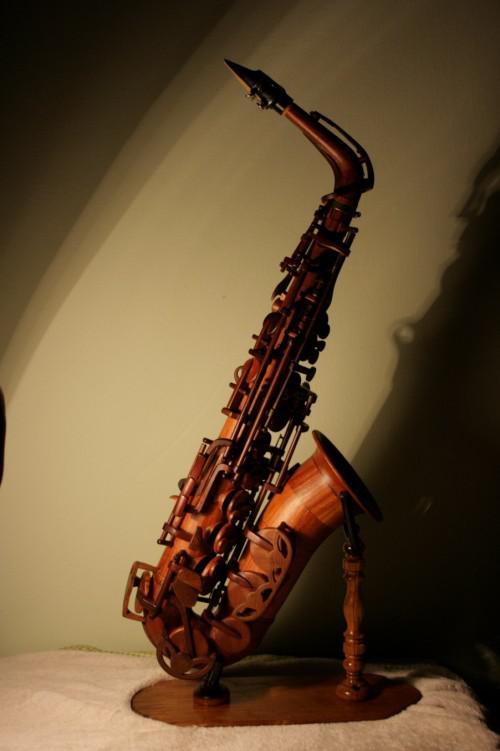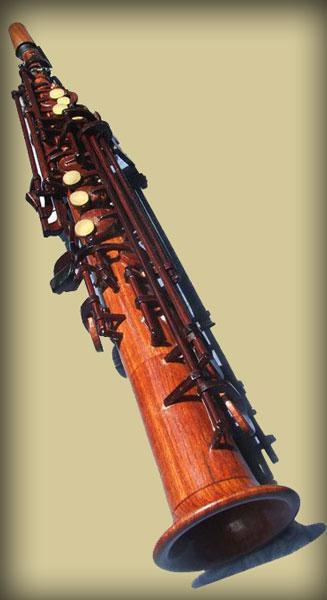The first image is the image on the left, the second image is the image on the right. Analyze the images presented: Is the assertion "The saxophone in the image on the left is on a stand." valid? Answer yes or no. Yes. 